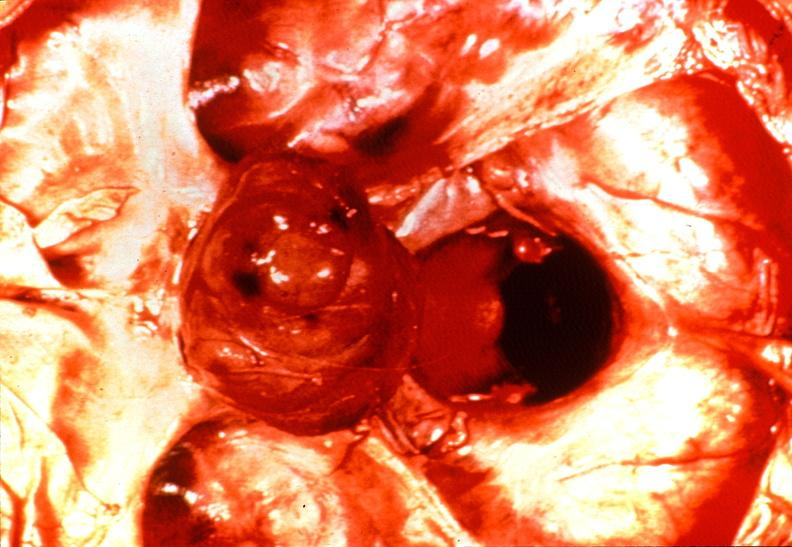s endocrine present?
Answer the question using a single word or phrase. Yes 